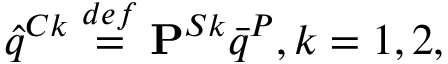Convert formula to latex. <formula><loc_0><loc_0><loc_500><loc_500>\hat { q } ^ { C k } \overset { d e f } { = } P ^ { S k } \bar { q } ^ { P } , k = 1 , 2 ,</formula> 